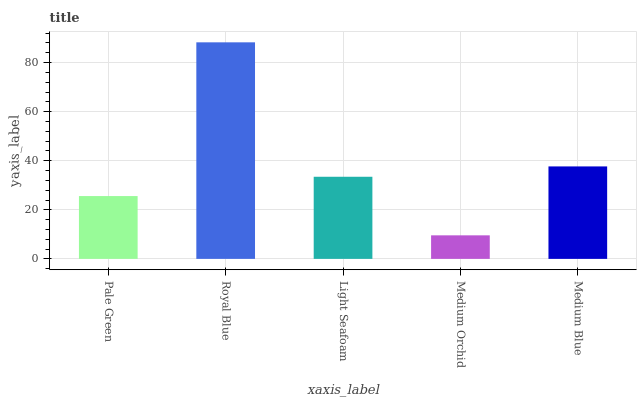Is Medium Orchid the minimum?
Answer yes or no. Yes. Is Royal Blue the maximum?
Answer yes or no. Yes. Is Light Seafoam the minimum?
Answer yes or no. No. Is Light Seafoam the maximum?
Answer yes or no. No. Is Royal Blue greater than Light Seafoam?
Answer yes or no. Yes. Is Light Seafoam less than Royal Blue?
Answer yes or no. Yes. Is Light Seafoam greater than Royal Blue?
Answer yes or no. No. Is Royal Blue less than Light Seafoam?
Answer yes or no. No. Is Light Seafoam the high median?
Answer yes or no. Yes. Is Light Seafoam the low median?
Answer yes or no. Yes. Is Pale Green the high median?
Answer yes or no. No. Is Medium Orchid the low median?
Answer yes or no. No. 